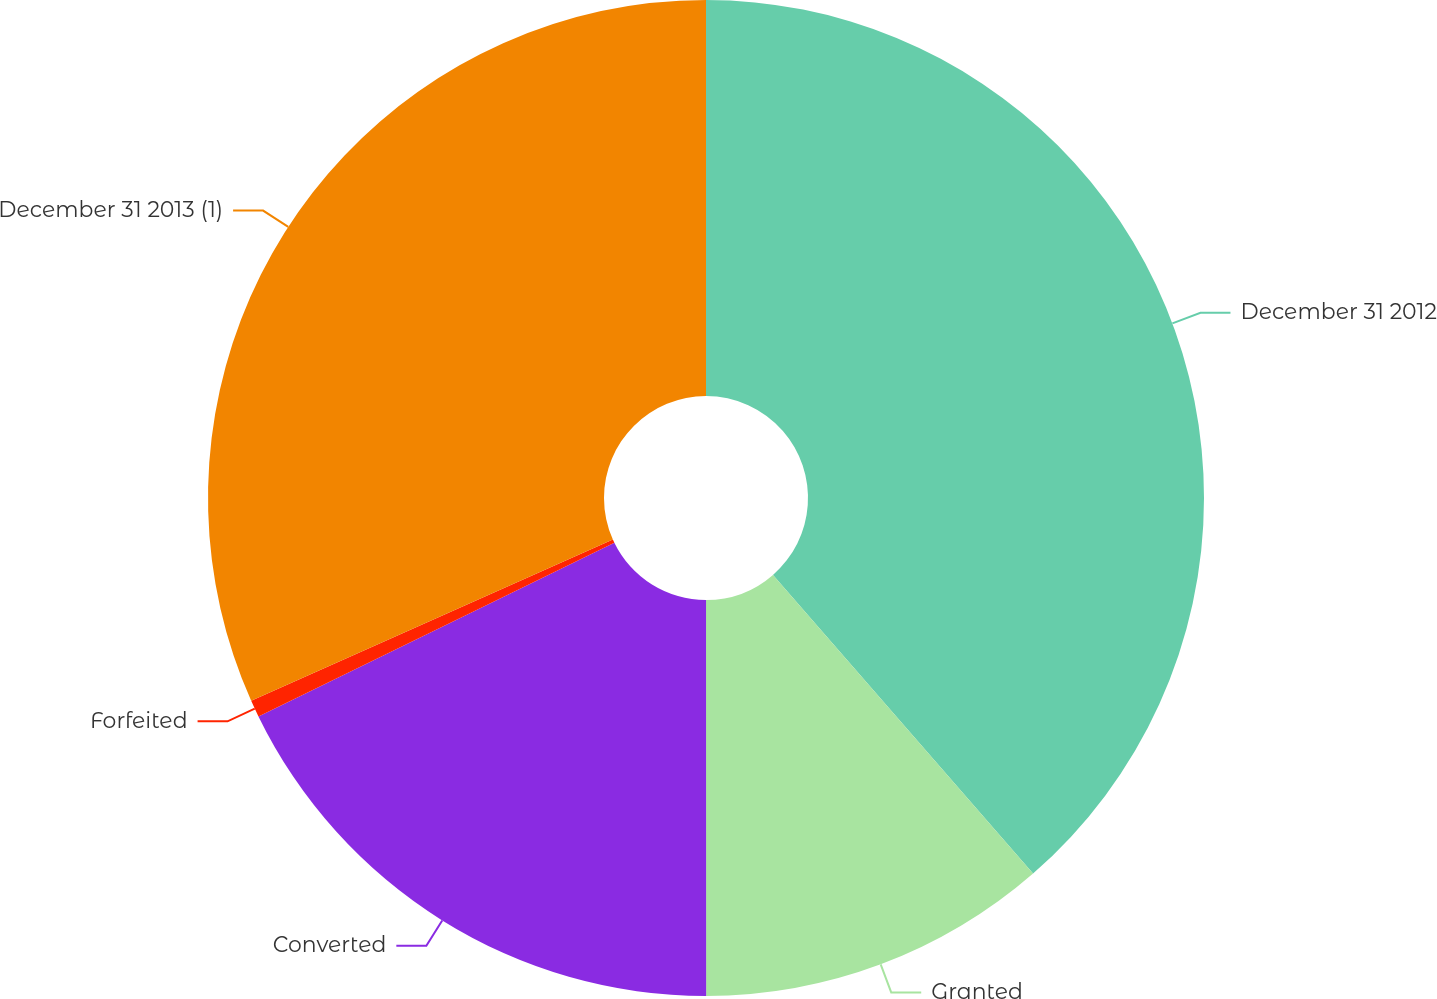<chart> <loc_0><loc_0><loc_500><loc_500><pie_chart><fcel>December 31 2012<fcel>Granted<fcel>Converted<fcel>Forfeited<fcel>December 31 2013 (1)<nl><fcel>38.6%<fcel>11.4%<fcel>17.78%<fcel>0.55%<fcel>31.68%<nl></chart> 